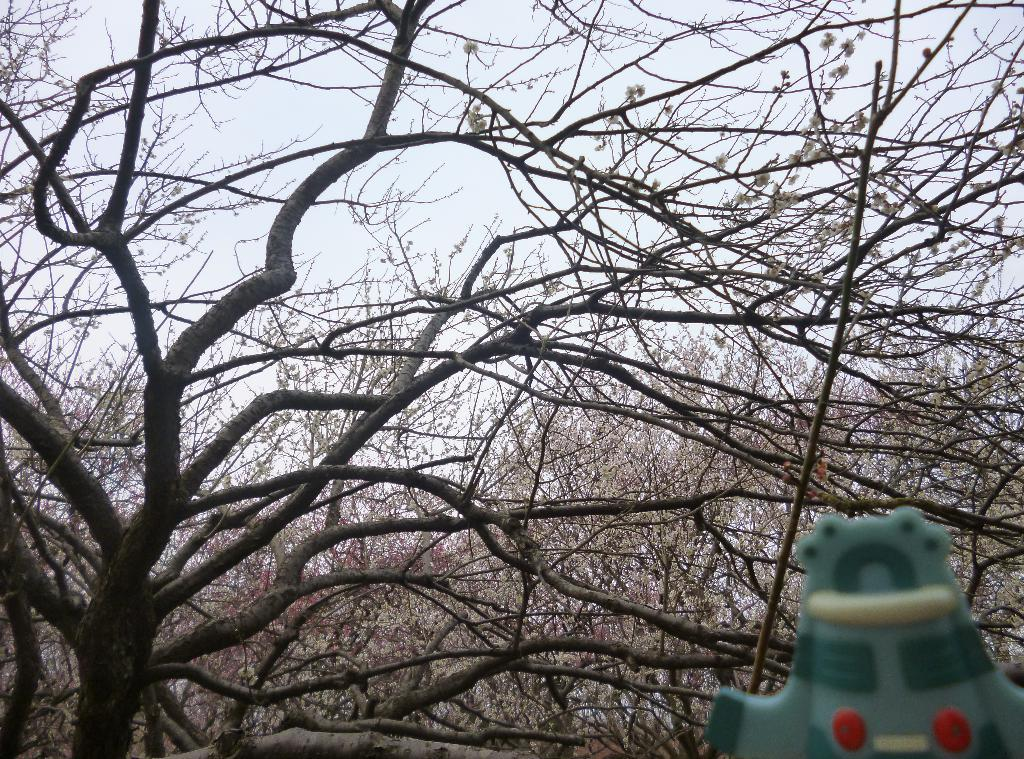What type of vegetation can be seen in the image? There are trees in the image. Can you describe the green object at the bottom right side of the image? Unfortunately, there is not enough information provided to accurately describe the green object at the bottom right side of the image. How does the dirt in the image turn into a development project? There is no dirt present in the image, so it cannot be turned into a development project. 